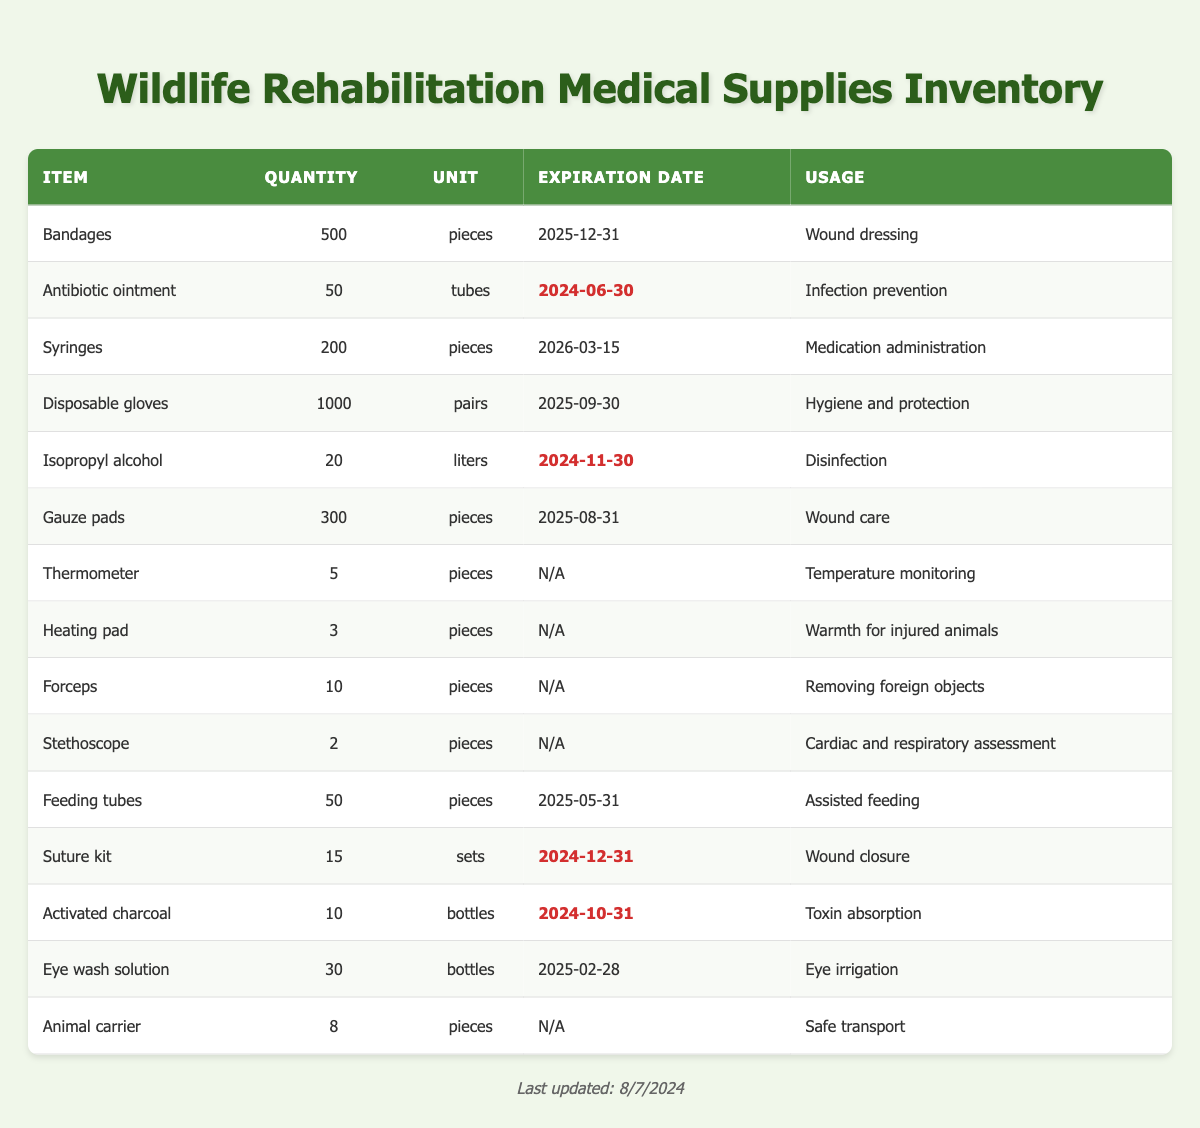What is the total quantity of bandages in the inventory? The table indicates that the quantity of bandages is listed as 500 pieces.
Answer: 500 pieces Which item has the earliest expiration date? By analyzing the expiration dates in the table, the item with the earliest date is "Antibiotic ointment," which expires on 2024-06-30.
Answer: Antibiotic ointment How many items have a quantity greater than 100? Checking the table, the items with quantities greater than 100 are Bandages (500), Syringes (200), Disposable gloves (1000), Gauze pads (300), Feeding tubes (50), and Animal carrier (8). That totals 5 items overall.
Answer: 5 Is there any item that is expiring in less than 6 months from the current date? Today's date is set for this context, and evaluating the expiration dates in the table, "Antibiotic ointment" and "Suture kit" are expiring within the next 6 months. Therefore, the answer is yes.
Answer: Yes What is the total number of items that are listed as 'pieces'? The items categorized as 'pieces' in the table are Bandages (500), Syringes (200), Gauze pads (300), Thermometer (5), Heating pad (3), Forceps (10), Stethoscope (2), Feeding tubes (50), and Animal carrier (8). Summing these gives us a total of 1078 pieces.
Answer: 1078 pieces Are there more disposable gloves or syringes available? Examining the table shows that there are 1000 pairs of disposable gloves and 200 pieces of syringes. Since 1000 is more than 200, the answer is that there are more disposable gloves.
Answer: Yes What percentage of the items are set to expire in the year 2024? The total number of items is 15. The items expiring in 2024 include Antibiotic ointment, Isopropyl alcohol, Suture kit, Activated charcoal, and Eye wash solution (5 items). To find the percentage, we calculate (5/15) * 100 = 33.33%.
Answer: 33.33% What is the average quantity of the medical supplies listed? To find the average, first, sum the quantities (500 + 50 + 200 + 1000 + 20 + 300 + 5 + 3 + 10 + 2 + 50 + 15 + 10 + 30 + 8 = 2193) and divide by the number of items (15). Hence, 2193 / 15 = 146.2.
Answer: 146.2 Which items require the use of protective equipment when handling? The items that require protective equipment include Disposable gloves (for hygiene and protection) and Isopropyl alcohol (for disinfection). Gloves are necessary when administering treatments involving alcohol, so the answer is these two items.
Answer: Disposable gloves and Isopropyl alcohol 